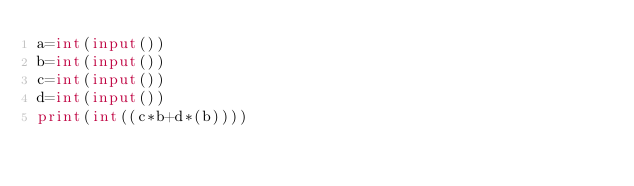Convert code to text. <code><loc_0><loc_0><loc_500><loc_500><_Python_>a=int(input())
b=int(input())
c=int(input())
d=int(input())
print(int((c*b+d*(b))))</code> 